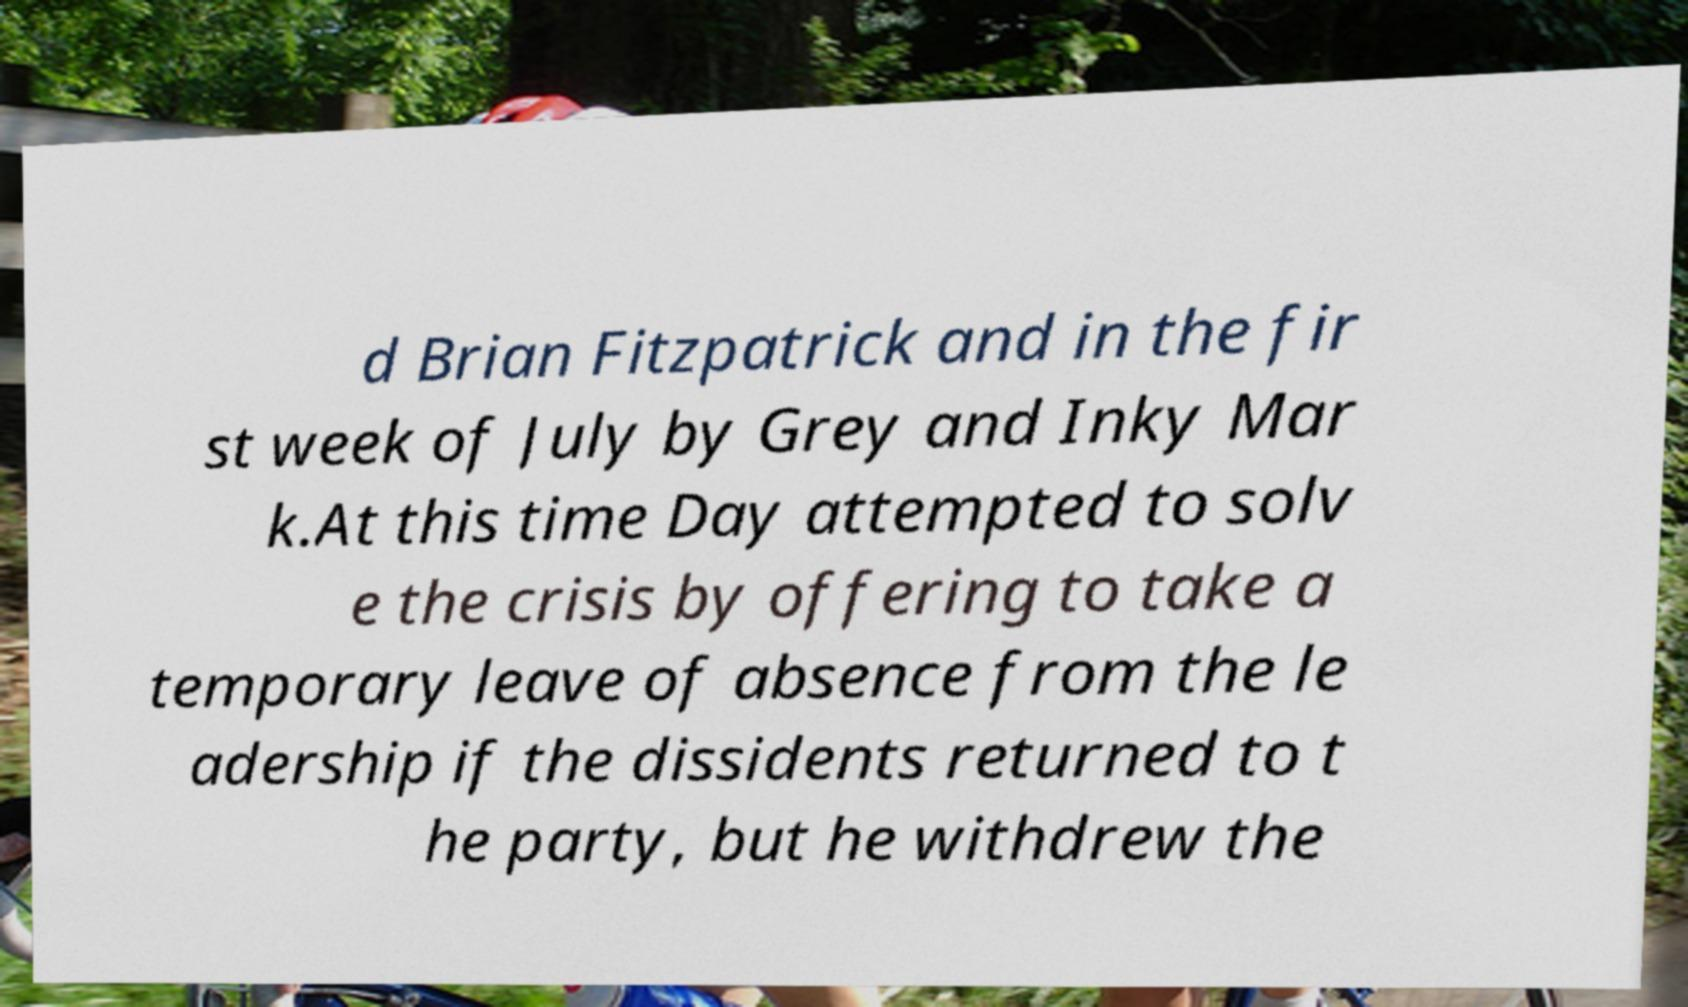I need the written content from this picture converted into text. Can you do that? d Brian Fitzpatrick and in the fir st week of July by Grey and Inky Mar k.At this time Day attempted to solv e the crisis by offering to take a temporary leave of absence from the le adership if the dissidents returned to t he party, but he withdrew the 